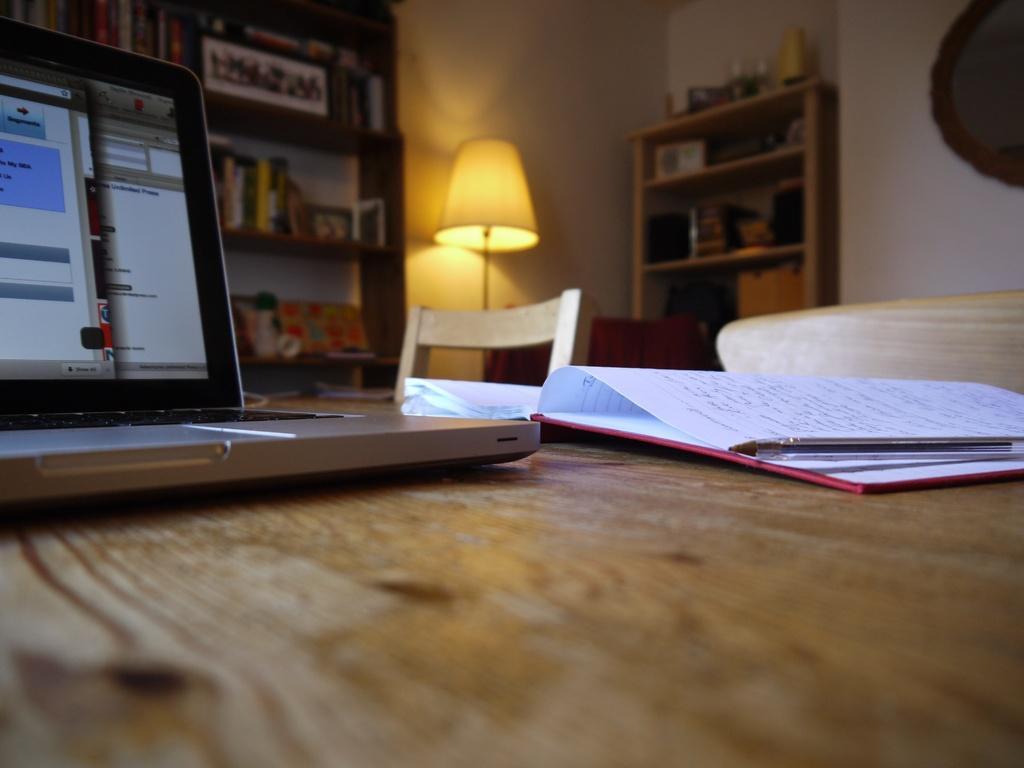Could you give a brief overview of what you see in this image? This image is taken inside a room. At the bottom of the image there is a table and top of that a book, a pen and a laptop is present on it. At the background there is a wall, a book shelf and few books in it and a lamp with an empty chairs. 